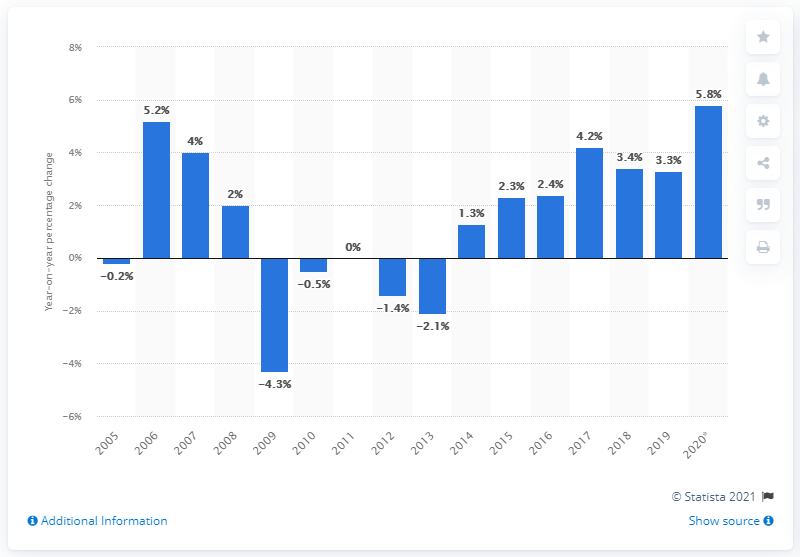Draw attention to some important aspects in this diagram. Since 2005, the combined sales turnover of the retail trade in the Netherlands has experienced significant fluctuations. 